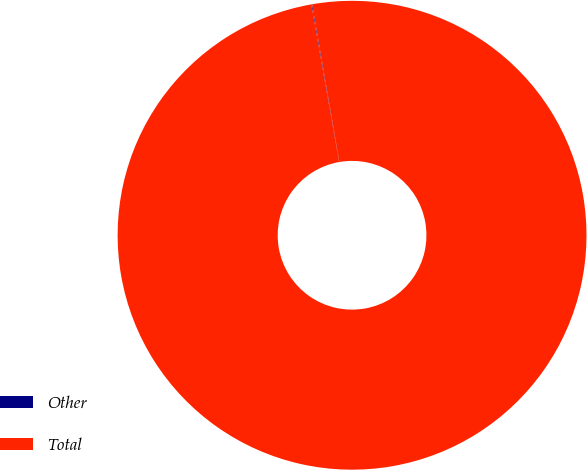<chart> <loc_0><loc_0><loc_500><loc_500><pie_chart><fcel>Other<fcel>Total<nl><fcel>0.05%<fcel>99.95%<nl></chart> 